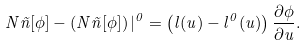Convert formula to latex. <formula><loc_0><loc_0><loc_500><loc_500>N \tilde { n } [ \phi ] - \left ( N \tilde { n } [ \phi ] \right ) | ^ { 0 } = \left ( l ( u ) - l ^ { 0 } ( u ) \right ) \frac { \partial \phi } { \partial u } .</formula> 